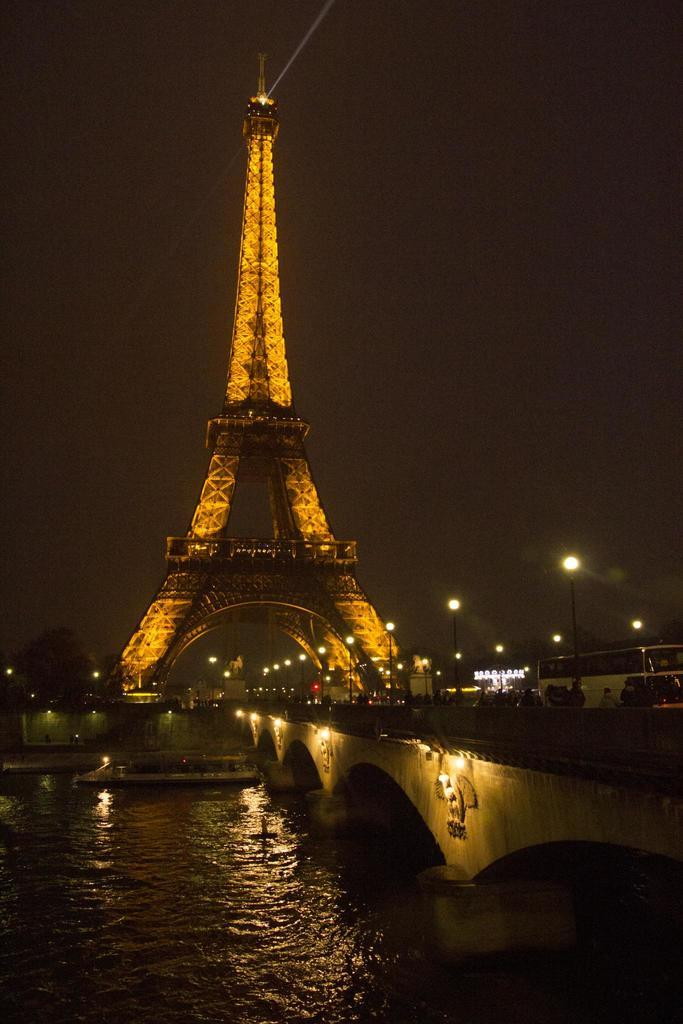What is the main subject of the image? There is a boat on the water in the image. What other structures or objects can be seen in the image? There is a bridge in the right corner of the image, and the Eiffel Tower is visible in the background. What type of lighting is present in the background of the image? There are street lights in the background of the image. Can you tell me how many boys are playing with a plant near the boat in the image? There are no boys or plants present in the image; it features a boat on the water, a bridge, the Eiffel Tower, and street lights. 